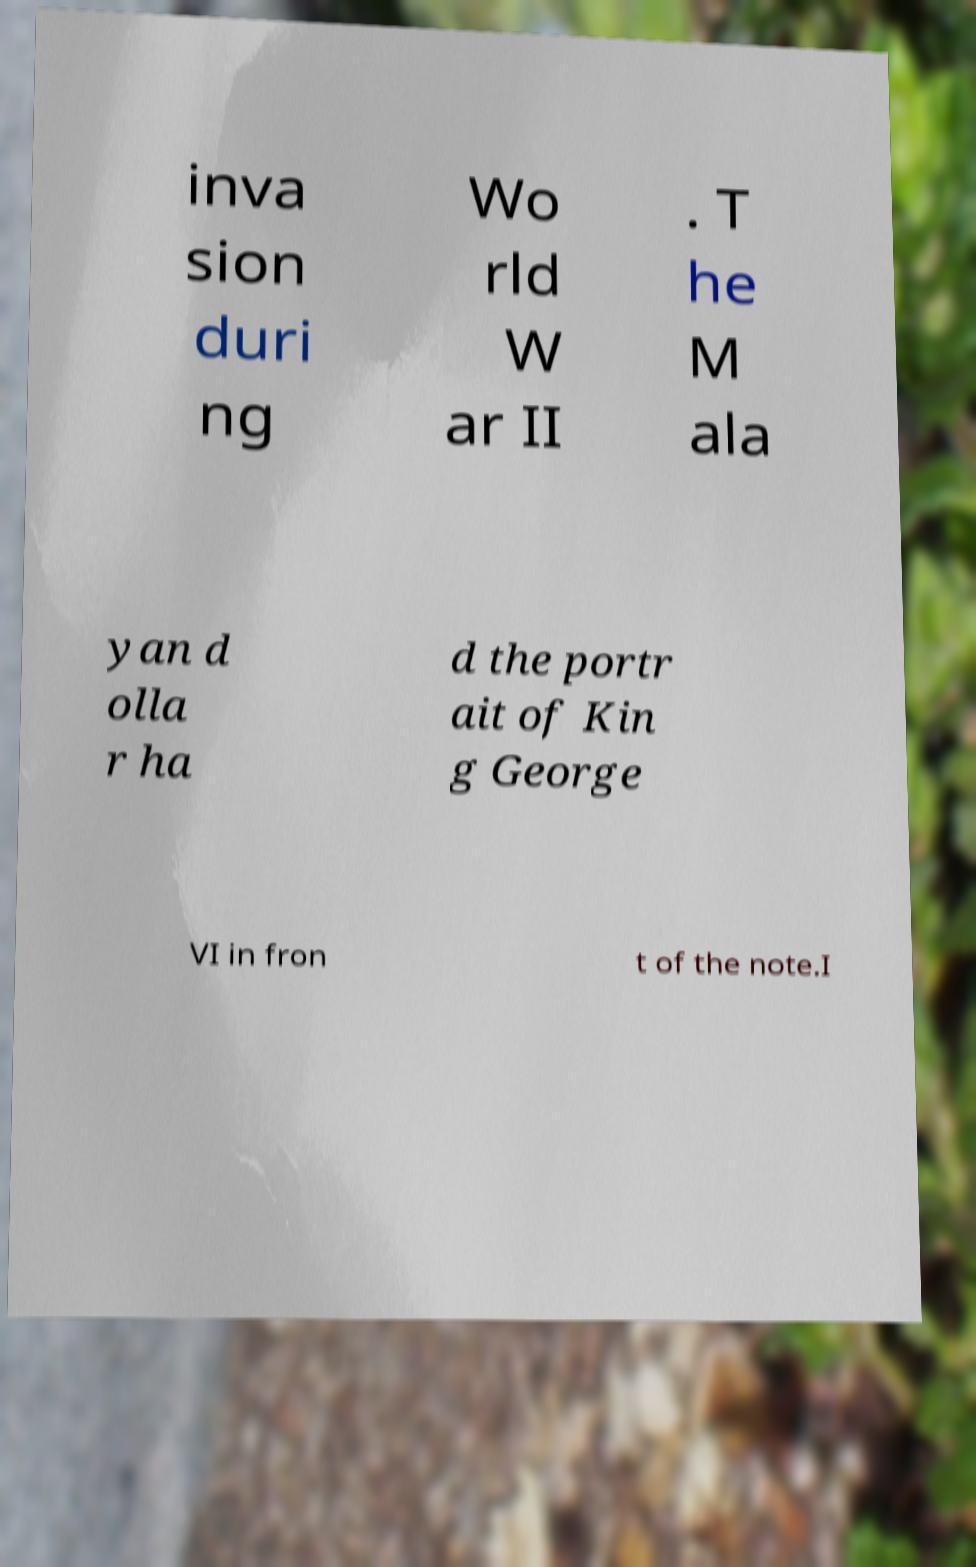Can you accurately transcribe the text from the provided image for me? inva sion duri ng Wo rld W ar II . T he M ala yan d olla r ha d the portr ait of Kin g George VI in fron t of the note.I 